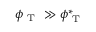Convert formula to latex. <formula><loc_0><loc_0><loc_500><loc_500>\phi _ { T } \gg \phi _ { T } ^ { * }</formula> 